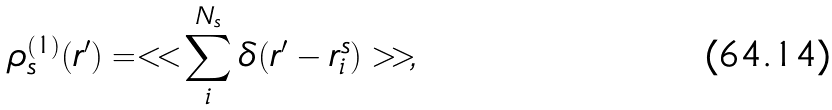Convert formula to latex. <formula><loc_0><loc_0><loc_500><loc_500>\rho ^ { ( 1 ) } _ { s } ( { r } ^ { \prime } ) = < < \sum _ { i } ^ { N _ { s } } \delta ( { r } ^ { \prime } - { r ^ { s } _ { i } } ) > > ,</formula> 